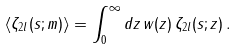<formula> <loc_0><loc_0><loc_500><loc_500>\langle \zeta _ { 2 l } ( s ; m ) \rangle = \int _ { 0 } ^ { \infty } d z \, w ( z ) \, \zeta _ { 2 l } ( s ; z ) \, .</formula> 